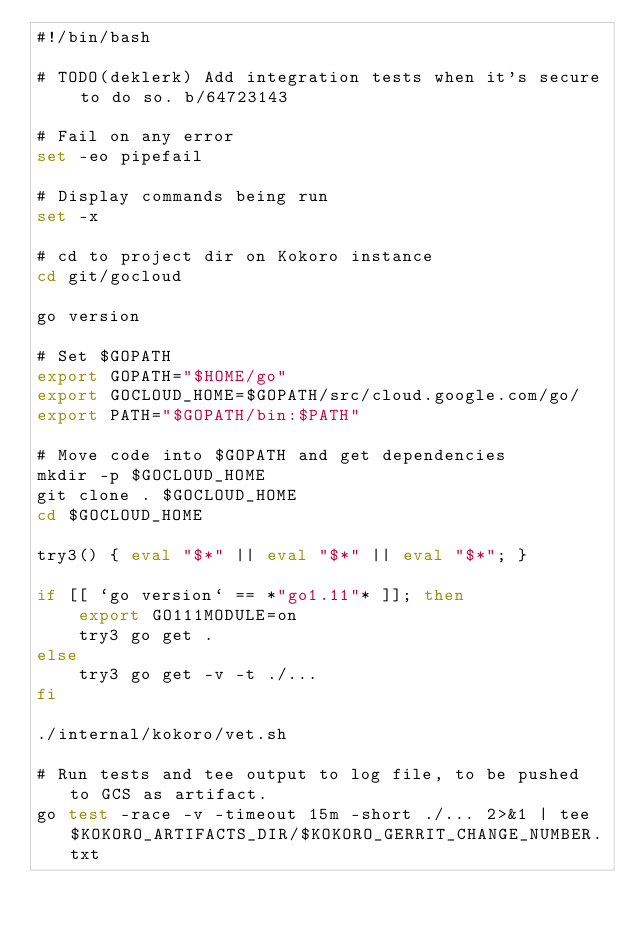Convert code to text. <code><loc_0><loc_0><loc_500><loc_500><_Bash_>#!/bin/bash

# TODO(deklerk) Add integration tests when it's secure to do so. b/64723143

# Fail on any error
set -eo pipefail

# Display commands being run
set -x

# cd to project dir on Kokoro instance
cd git/gocloud

go version

# Set $GOPATH
export GOPATH="$HOME/go"
export GOCLOUD_HOME=$GOPATH/src/cloud.google.com/go/
export PATH="$GOPATH/bin:$PATH"

# Move code into $GOPATH and get dependencies
mkdir -p $GOCLOUD_HOME
git clone . $GOCLOUD_HOME
cd $GOCLOUD_HOME

try3() { eval "$*" || eval "$*" || eval "$*"; }

if [[ `go version` == *"go1.11"* ]]; then
    export GO111MODULE=on
    try3 go get .
else
    try3 go get -v -t ./...
fi

./internal/kokoro/vet.sh

# Run tests and tee output to log file, to be pushed to GCS as artifact.
go test -race -v -timeout 15m -short ./... 2>&1 | tee $KOKORO_ARTIFACTS_DIR/$KOKORO_GERRIT_CHANGE_NUMBER.txt
</code> 